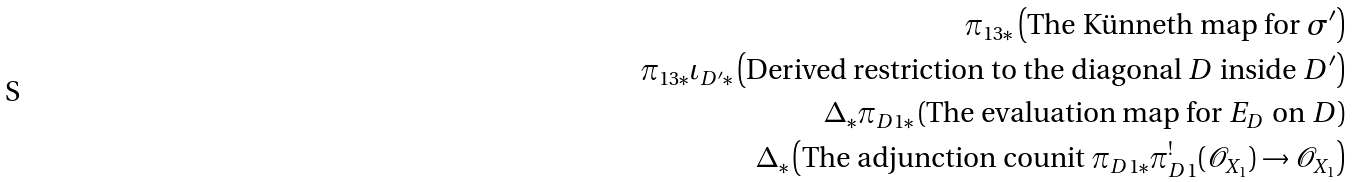Convert formula to latex. <formula><loc_0><loc_0><loc_500><loc_500>\pi _ { 1 3 * } \left ( \text {The K{\"u}nneth map for } \sigma ^ { \prime } \right ) \\ \pi _ { 1 3 * } \iota _ { D ^ { \prime } * } \left ( \text {Derived restriction to the diagonal } D \text { inside } D ^ { \prime } \right ) \\ \Delta _ { * } \pi _ { D 1 * } \left ( \text {The evaluation map for } E _ { D } \text { on } D \right ) \\ \Delta _ { * } \left ( \text {The adjunction counit } \pi _ { D 1 * } \pi ^ { ! } _ { D 1 } ( \mathcal { O } _ { X _ { 1 } } ) \rightarrow \mathcal { O } _ { X _ { 1 } } \right )</formula> 